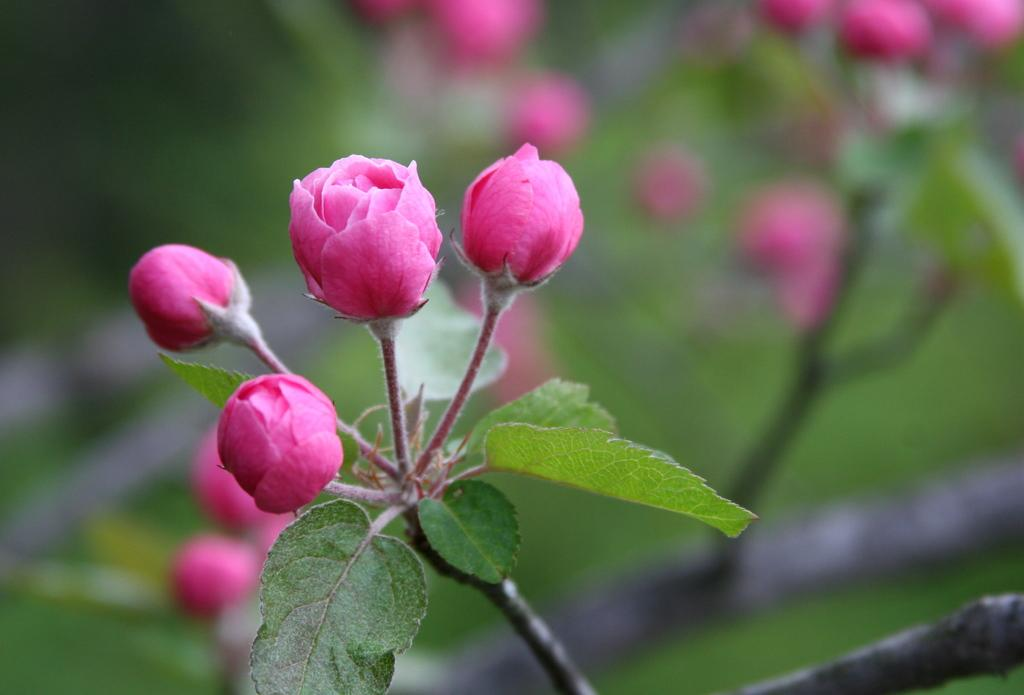Where was the image taken? The image was taken outdoors. What can be seen in the background of the image? There are plants in the background of the image. What is the main subject of the image? There is a plant with rose buds in the middle of the image. What color are the rose buds? The rose buds are pink in color. What type of account is being discussed in the image? There is no account being discussed in the image; it features a plant with rose buds. Can you see a bike in the scene? There is no bike present in the image. 